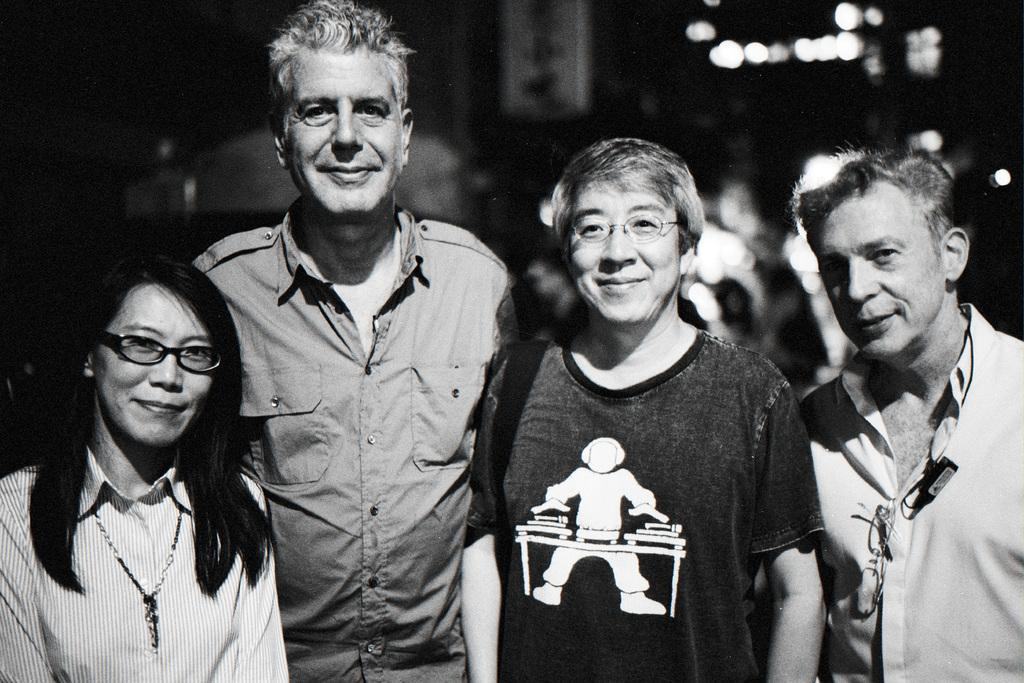How would you summarize this image in a sentence or two? This is a black and white image, in this image there is are two men and two women standing, in the background it is blurred. 